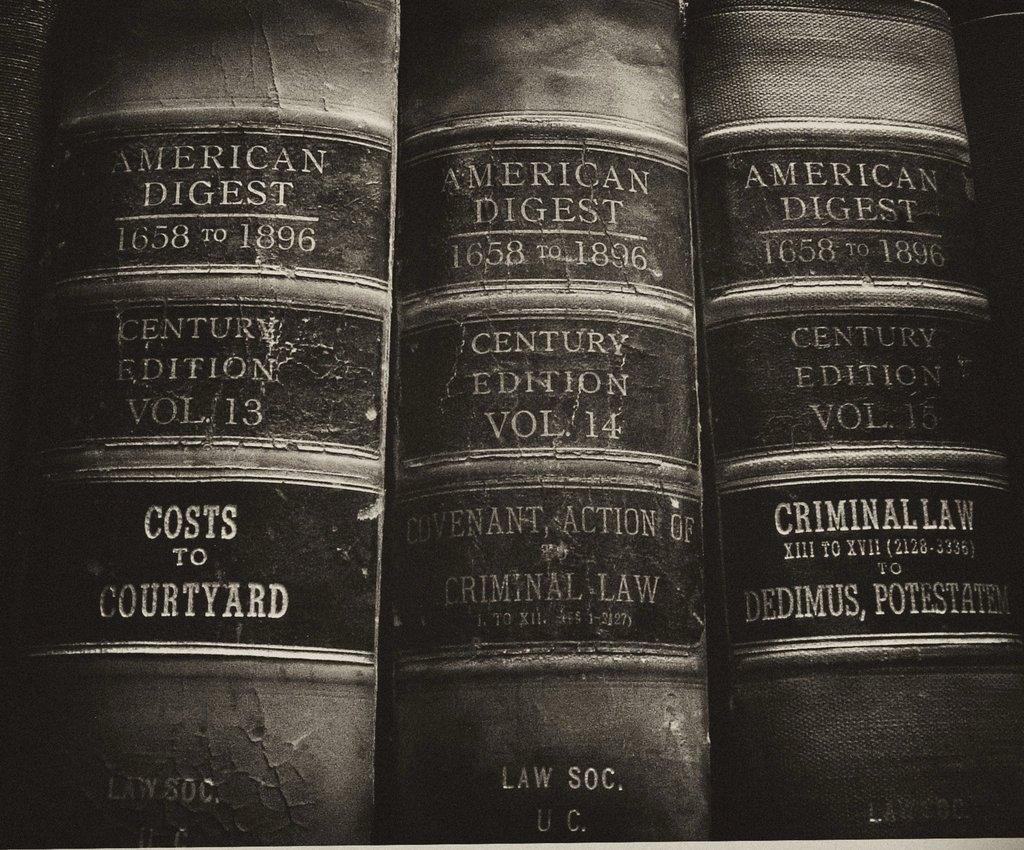What years does the bookset span?
Make the answer very short. 1658 to 1896. 